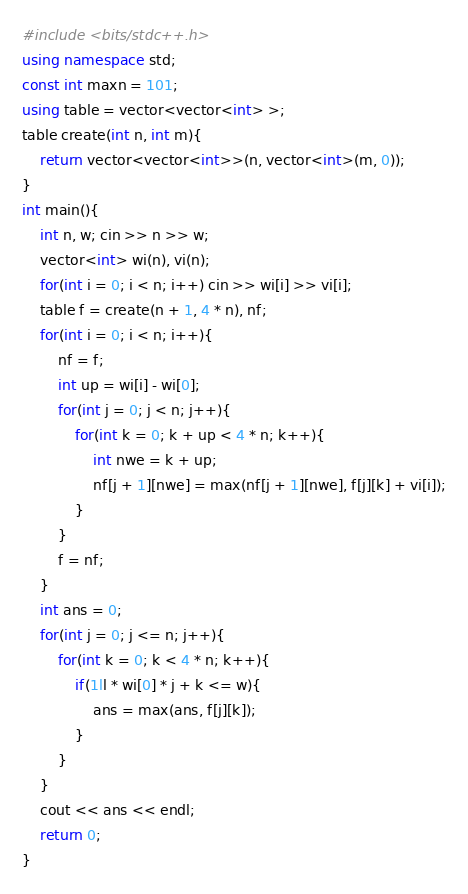Convert code to text. <code><loc_0><loc_0><loc_500><loc_500><_C++_>#include <bits/stdc++.h>
using namespace std;
const int maxn = 101;
using table = vector<vector<int> >;
table create(int n, int m){
	return vector<vector<int>>(n, vector<int>(m, 0));
}
int main(){
	int n, w; cin >> n >> w;
	vector<int> wi(n), vi(n);
	for(int i = 0; i < n; i++) cin >> wi[i] >> vi[i];
	table f = create(n + 1, 4 * n), nf;
	for(int i = 0; i < n; i++){
		nf = f;
		int up = wi[i] - wi[0];
		for(int j = 0; j < n; j++){
			for(int k = 0; k + up < 4 * n; k++){
				int nwe = k + up;
				nf[j + 1][nwe] = max(nf[j + 1][nwe], f[j][k] + vi[i]);
			}
		}	
		f = nf;
	}
	int ans = 0;
	for(int j = 0; j <= n; j++){
		for(int k = 0; k < 4 * n; k++){
			if(1ll * wi[0] * j + k <= w){
				ans = max(ans, f[j][k]);
			}
		}
	}
	cout << ans << endl;
	return 0;
}

</code> 